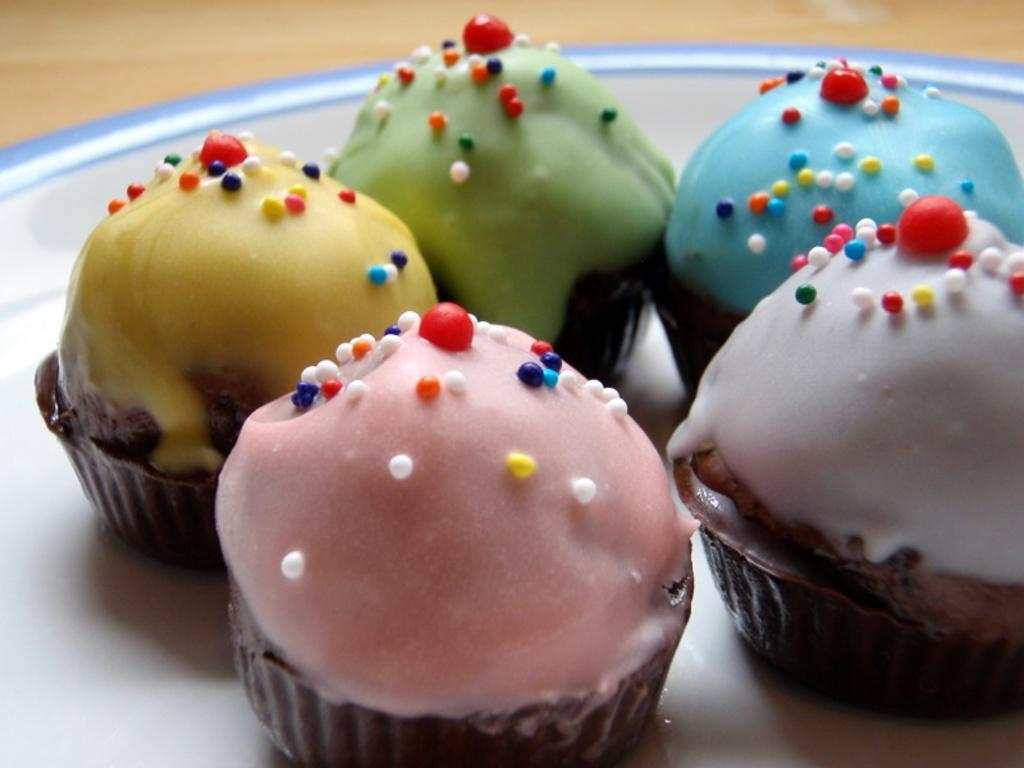What is the main piece of furniture in the image? There is a table in the image. What type of food is on the table? There are cupcakes on the table. Is there any other tableware or dishware visible on the table? Yes, there is a plate on the table. What type of sheet is draped over the cupcakes in the image? There is no sheet present in the image; the cupcakes are not covered. 